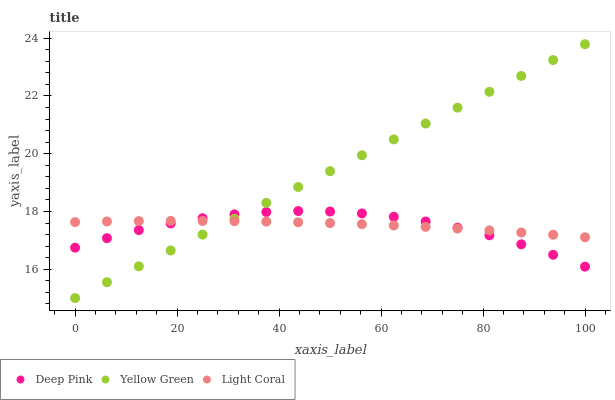Does Deep Pink have the minimum area under the curve?
Answer yes or no. Yes. Does Yellow Green have the maximum area under the curve?
Answer yes or no. Yes. Does Yellow Green have the minimum area under the curve?
Answer yes or no. No. Does Deep Pink have the maximum area under the curve?
Answer yes or no. No. Is Yellow Green the smoothest?
Answer yes or no. Yes. Is Deep Pink the roughest?
Answer yes or no. Yes. Is Deep Pink the smoothest?
Answer yes or no. No. Is Yellow Green the roughest?
Answer yes or no. No. Does Yellow Green have the lowest value?
Answer yes or no. Yes. Does Deep Pink have the lowest value?
Answer yes or no. No. Does Yellow Green have the highest value?
Answer yes or no. Yes. Does Deep Pink have the highest value?
Answer yes or no. No. Does Deep Pink intersect Yellow Green?
Answer yes or no. Yes. Is Deep Pink less than Yellow Green?
Answer yes or no. No. Is Deep Pink greater than Yellow Green?
Answer yes or no. No. 